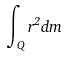<formula> <loc_0><loc_0><loc_500><loc_500>\int _ { Q } r ^ { 2 } d m</formula> 